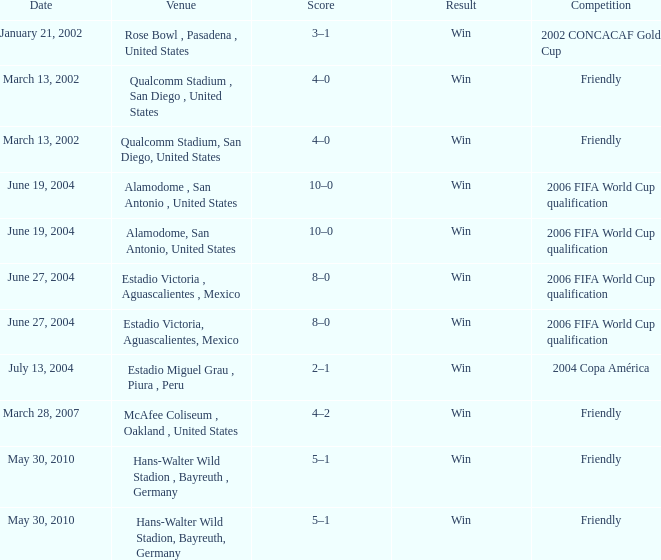What is the significance or outcome related to january 21, 2002? Win. 